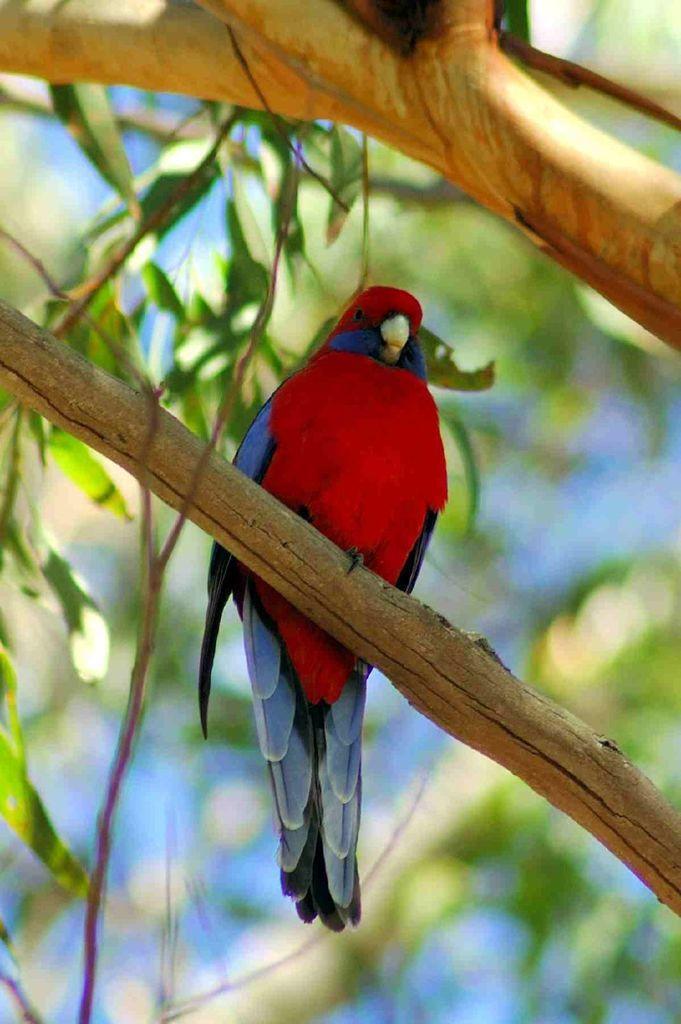How would you summarize this image in a sentence or two? In this image we can see the bird on the tree and there is the blur background. 